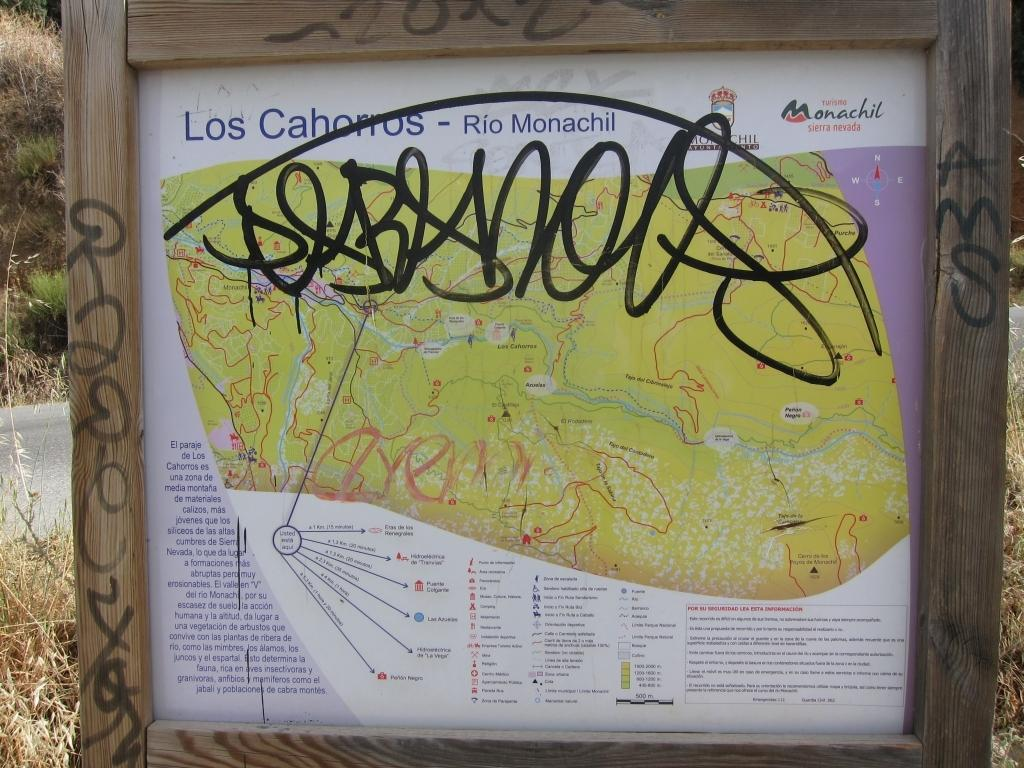<image>
Create a compact narrative representing the image presented. A trail map for Los Cahorros has graffiti scrawled on it. 